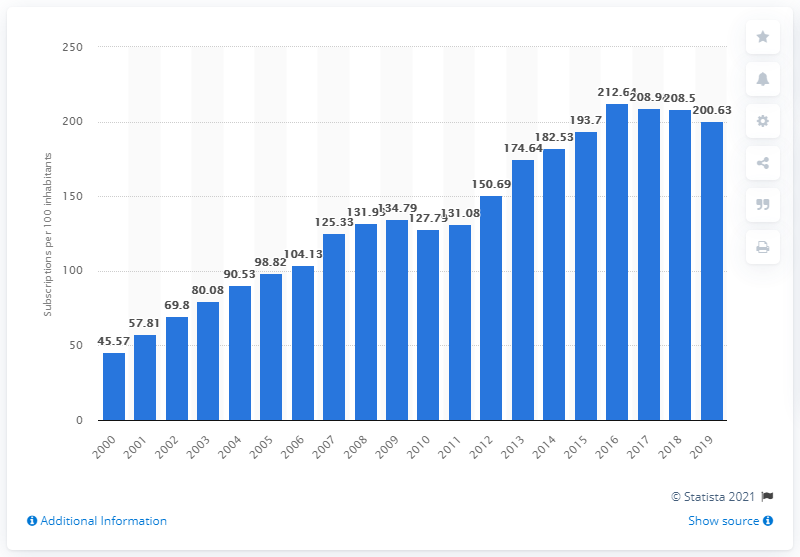Give some essential details in this illustration. In the United Arab Emirates, there were an average of 200.63 mobile cellular subscriptions for every 100 people between 2000 and 2019. 